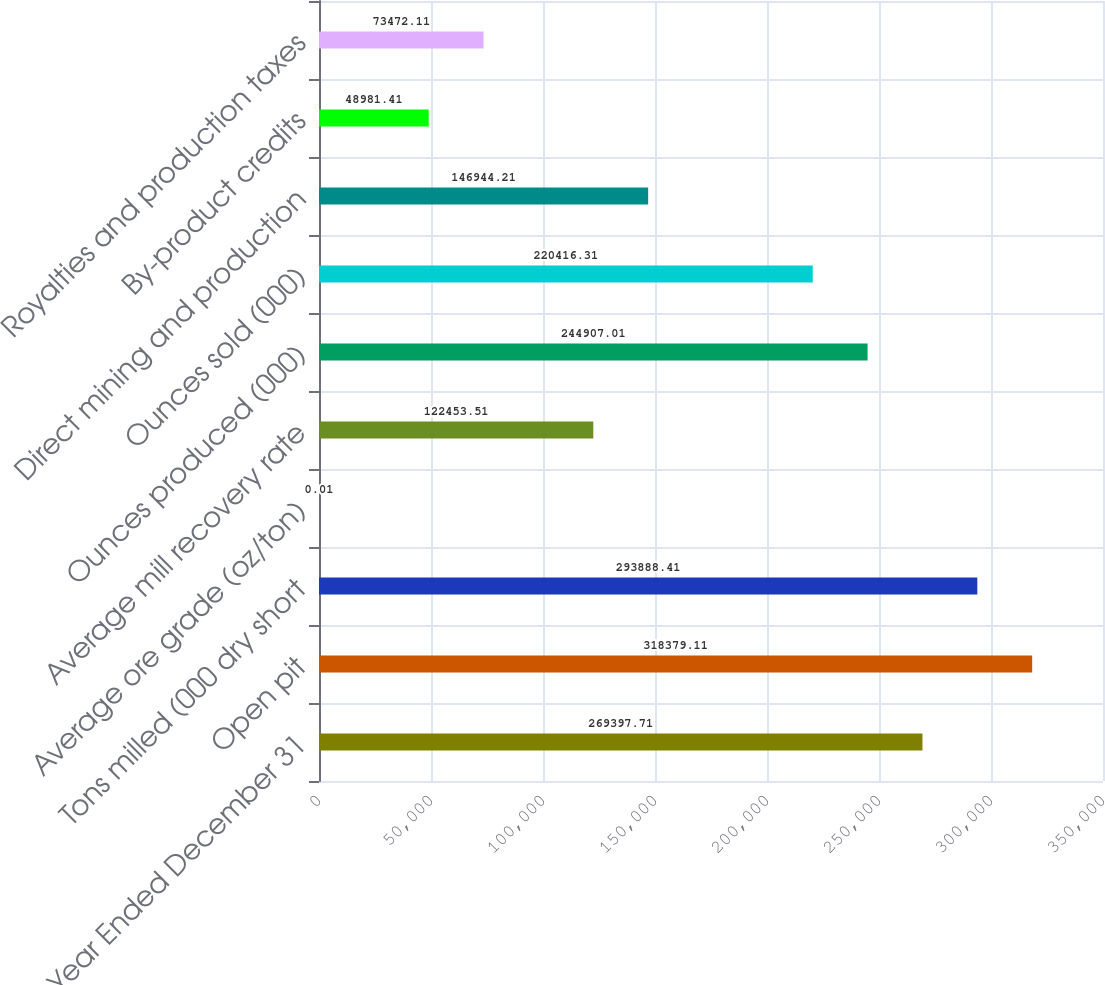Convert chart. <chart><loc_0><loc_0><loc_500><loc_500><bar_chart><fcel>Year Ended December 31<fcel>Open pit<fcel>Tons milled (000 dry short<fcel>Average ore grade (oz/ton)<fcel>Average mill recovery rate<fcel>Ounces produced (000)<fcel>Ounces sold (000)<fcel>Direct mining and production<fcel>By-product credits<fcel>Royalties and production taxes<nl><fcel>269398<fcel>318379<fcel>293888<fcel>0.01<fcel>122454<fcel>244907<fcel>220416<fcel>146944<fcel>48981.4<fcel>73472.1<nl></chart> 